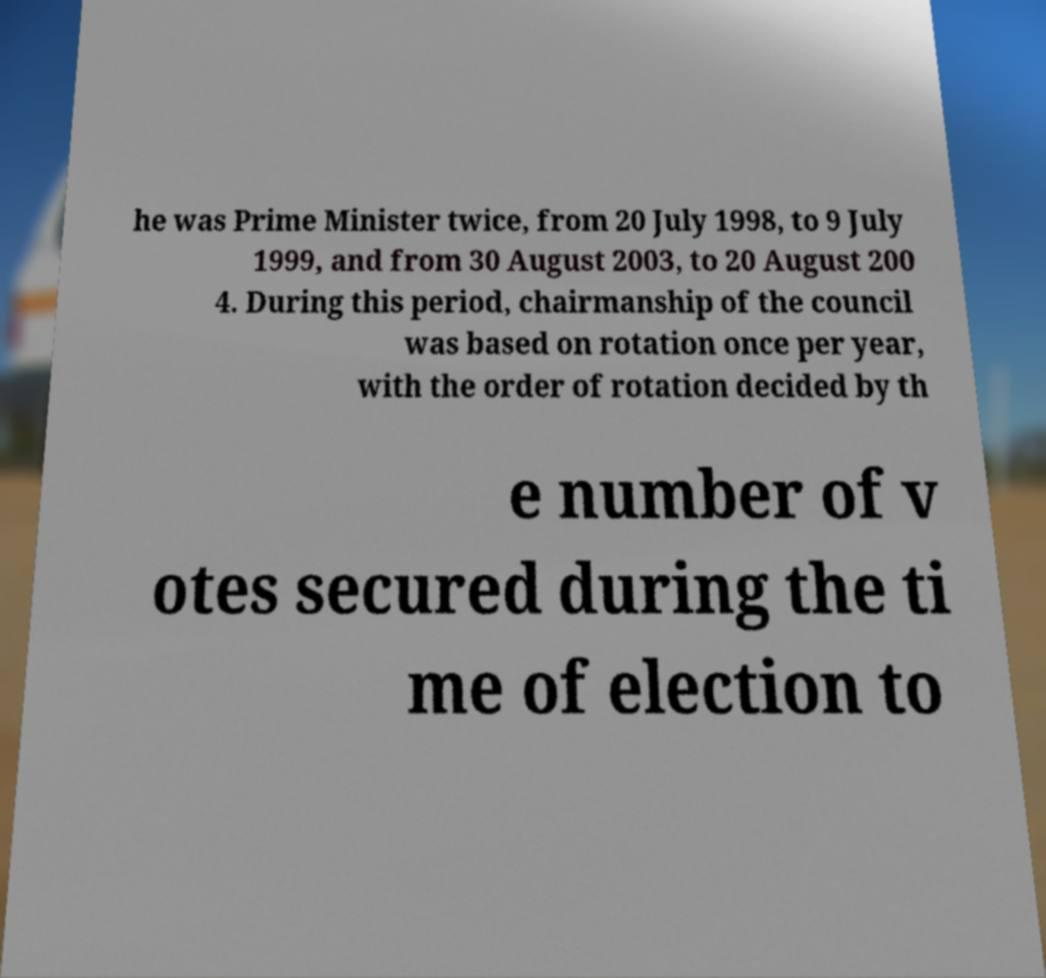Could you assist in decoding the text presented in this image and type it out clearly? he was Prime Minister twice, from 20 July 1998, to 9 July 1999, and from 30 August 2003, to 20 August 200 4. During this period, chairmanship of the council was based on rotation once per year, with the order of rotation decided by th e number of v otes secured during the ti me of election to 